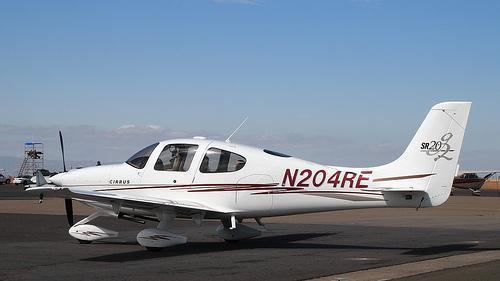How many planes are there?
Give a very brief answer. 1. 